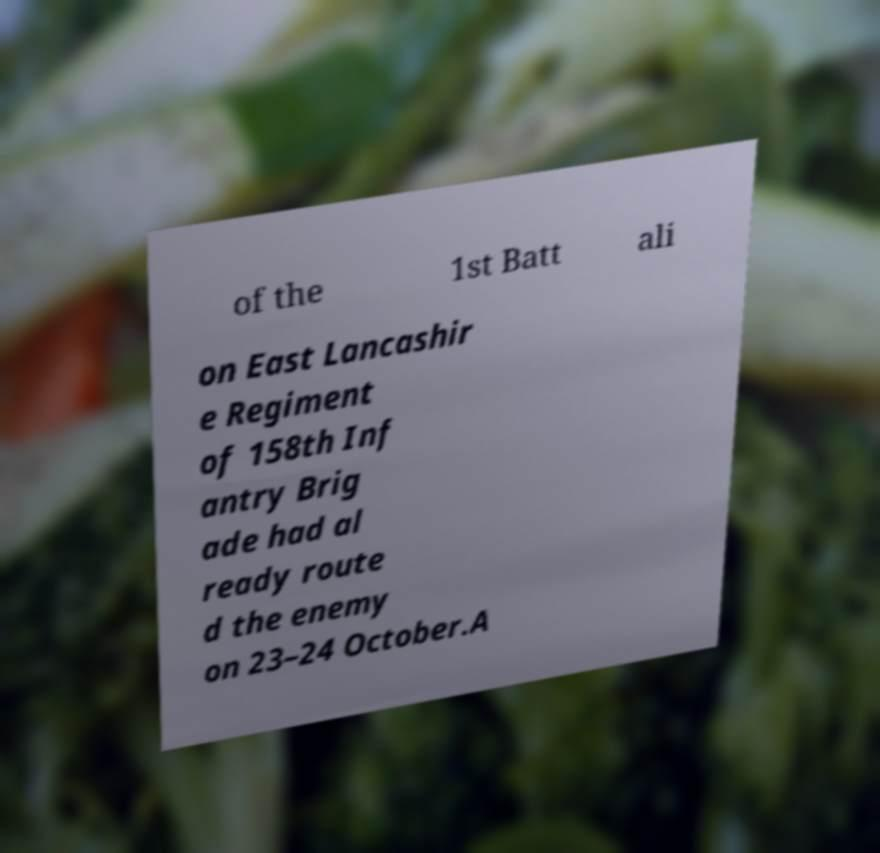Can you accurately transcribe the text from the provided image for me? of the 1st Batt ali on East Lancashir e Regiment of 158th Inf antry Brig ade had al ready route d the enemy on 23–24 October.A 